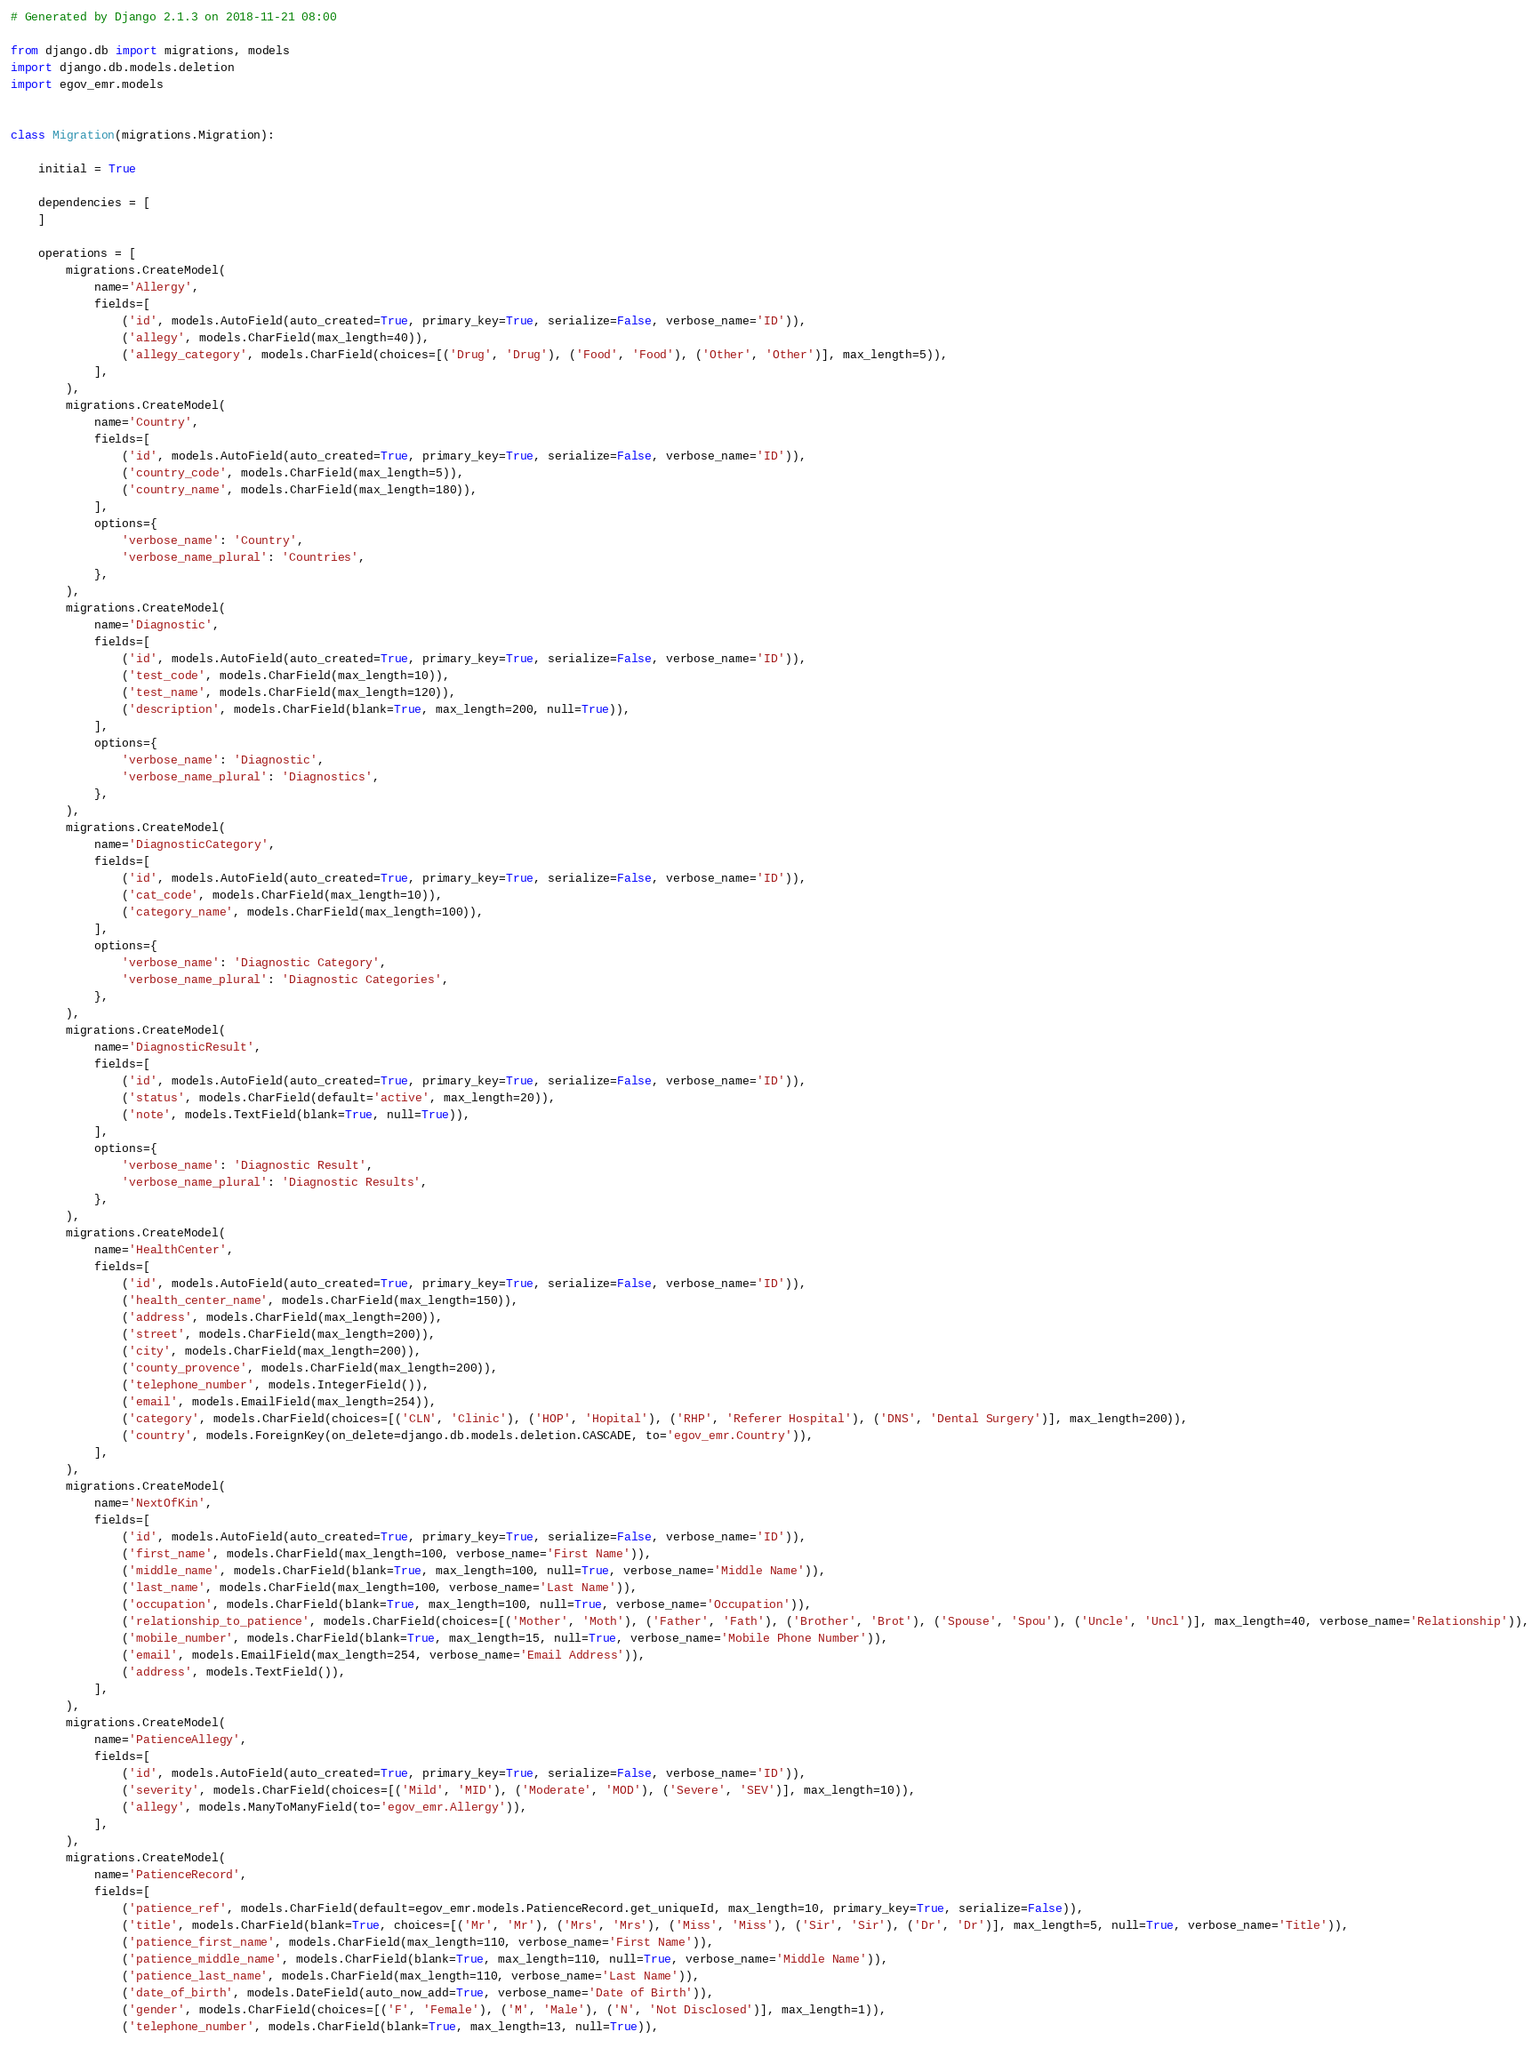<code> <loc_0><loc_0><loc_500><loc_500><_Python_># Generated by Django 2.1.3 on 2018-11-21 08:00

from django.db import migrations, models
import django.db.models.deletion
import egov_emr.models


class Migration(migrations.Migration):

    initial = True

    dependencies = [
    ]

    operations = [
        migrations.CreateModel(
            name='Allergy',
            fields=[
                ('id', models.AutoField(auto_created=True, primary_key=True, serialize=False, verbose_name='ID')),
                ('allegy', models.CharField(max_length=40)),
                ('allegy_category', models.CharField(choices=[('Drug', 'Drug'), ('Food', 'Food'), ('Other', 'Other')], max_length=5)),
            ],
        ),
        migrations.CreateModel(
            name='Country',
            fields=[
                ('id', models.AutoField(auto_created=True, primary_key=True, serialize=False, verbose_name='ID')),
                ('country_code', models.CharField(max_length=5)),
                ('country_name', models.CharField(max_length=180)),
            ],
            options={
                'verbose_name': 'Country',
                'verbose_name_plural': 'Countries',
            },
        ),
        migrations.CreateModel(
            name='Diagnostic',
            fields=[
                ('id', models.AutoField(auto_created=True, primary_key=True, serialize=False, verbose_name='ID')),
                ('test_code', models.CharField(max_length=10)),
                ('test_name', models.CharField(max_length=120)),
                ('description', models.CharField(blank=True, max_length=200, null=True)),
            ],
            options={
                'verbose_name': 'Diagnostic',
                'verbose_name_plural': 'Diagnostics',
            },
        ),
        migrations.CreateModel(
            name='DiagnosticCategory',
            fields=[
                ('id', models.AutoField(auto_created=True, primary_key=True, serialize=False, verbose_name='ID')),
                ('cat_code', models.CharField(max_length=10)),
                ('category_name', models.CharField(max_length=100)),
            ],
            options={
                'verbose_name': 'Diagnostic Category',
                'verbose_name_plural': 'Diagnostic Categories',
            },
        ),
        migrations.CreateModel(
            name='DiagnosticResult',
            fields=[
                ('id', models.AutoField(auto_created=True, primary_key=True, serialize=False, verbose_name='ID')),
                ('status', models.CharField(default='active', max_length=20)),
                ('note', models.TextField(blank=True, null=True)),
            ],
            options={
                'verbose_name': 'Diagnostic Result',
                'verbose_name_plural': 'Diagnostic Results',
            },
        ),
        migrations.CreateModel(
            name='HealthCenter',
            fields=[
                ('id', models.AutoField(auto_created=True, primary_key=True, serialize=False, verbose_name='ID')),
                ('health_center_name', models.CharField(max_length=150)),
                ('address', models.CharField(max_length=200)),
                ('street', models.CharField(max_length=200)),
                ('city', models.CharField(max_length=200)),
                ('county_provence', models.CharField(max_length=200)),
                ('telephone_number', models.IntegerField()),
                ('email', models.EmailField(max_length=254)),
                ('category', models.CharField(choices=[('CLN', 'Clinic'), ('HOP', 'Hopital'), ('RHP', 'Referer Hospital'), ('DNS', 'Dental Surgery')], max_length=200)),
                ('country', models.ForeignKey(on_delete=django.db.models.deletion.CASCADE, to='egov_emr.Country')),
            ],
        ),
        migrations.CreateModel(
            name='NextOfKin',
            fields=[
                ('id', models.AutoField(auto_created=True, primary_key=True, serialize=False, verbose_name='ID')),
                ('first_name', models.CharField(max_length=100, verbose_name='First Name')),
                ('middle_name', models.CharField(blank=True, max_length=100, null=True, verbose_name='Middle Name')),
                ('last_name', models.CharField(max_length=100, verbose_name='Last Name')),
                ('occupation', models.CharField(blank=True, max_length=100, null=True, verbose_name='Occupation')),
                ('relationship_to_patience', models.CharField(choices=[('Mother', 'Moth'), ('Father', 'Fath'), ('Brother', 'Brot'), ('Spouse', 'Spou'), ('Uncle', 'Uncl')], max_length=40, verbose_name='Relationship')),
                ('mobile_number', models.CharField(blank=True, max_length=15, null=True, verbose_name='Mobile Phone Number')),
                ('email', models.EmailField(max_length=254, verbose_name='Email Address')),
                ('address', models.TextField()),
            ],
        ),
        migrations.CreateModel(
            name='PatienceAllegy',
            fields=[
                ('id', models.AutoField(auto_created=True, primary_key=True, serialize=False, verbose_name='ID')),
                ('severity', models.CharField(choices=[('Mild', 'MID'), ('Moderate', 'MOD'), ('Severe', 'SEV')], max_length=10)),
                ('allegy', models.ManyToManyField(to='egov_emr.Allergy')),
            ],
        ),
        migrations.CreateModel(
            name='PatienceRecord',
            fields=[
                ('patience_ref', models.CharField(default=egov_emr.models.PatienceRecord.get_uniqueId, max_length=10, primary_key=True, serialize=False)),
                ('title', models.CharField(blank=True, choices=[('Mr', 'Mr'), ('Mrs', 'Mrs'), ('Miss', 'Miss'), ('Sir', 'Sir'), ('Dr', 'Dr')], max_length=5, null=True, verbose_name='Title')),
                ('patience_first_name', models.CharField(max_length=110, verbose_name='First Name')),
                ('patience_middle_name', models.CharField(blank=True, max_length=110, null=True, verbose_name='Middle Name')),
                ('patience_last_name', models.CharField(max_length=110, verbose_name='Last Name')),
                ('date_of_birth', models.DateField(auto_now_add=True, verbose_name='Date of Birth')),
                ('gender', models.CharField(choices=[('F', 'Female'), ('M', 'Male'), ('N', 'Not Disclosed')], max_length=1)),
                ('telephone_number', models.CharField(blank=True, max_length=13, null=True)),</code> 